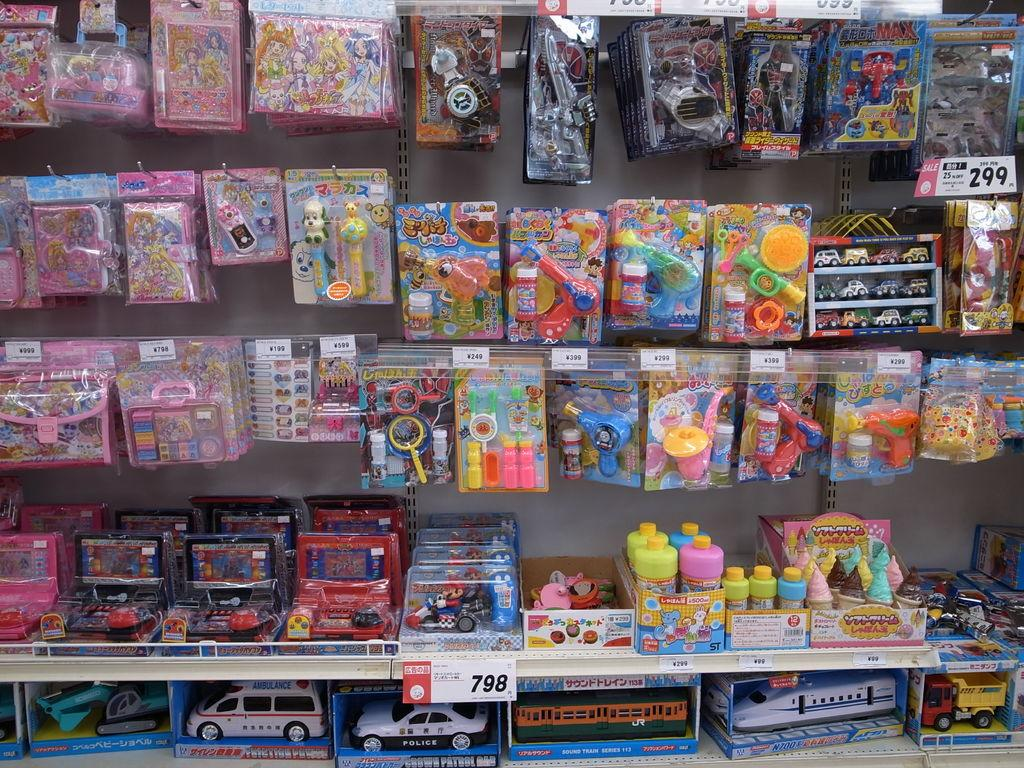<image>
Summarize the visual content of the image. a group of toys and one that has ambulance written on it 